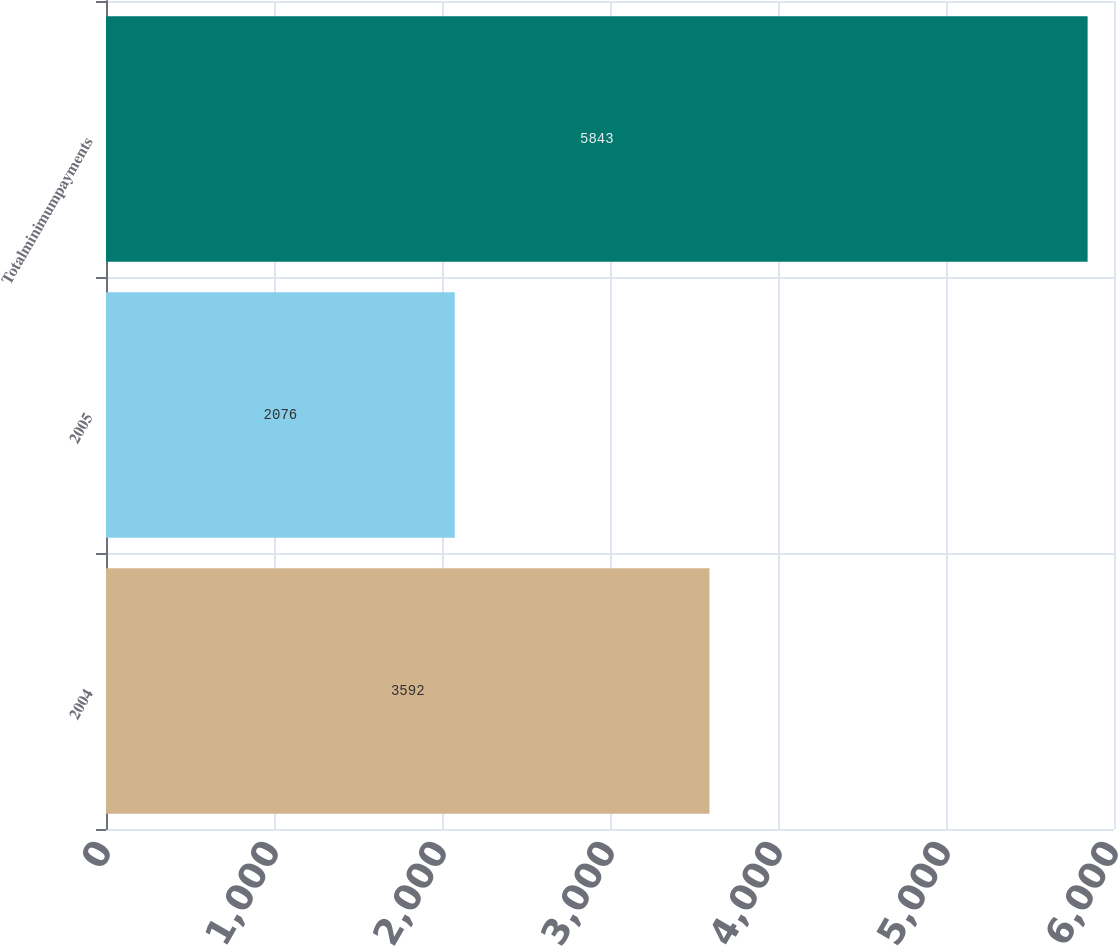Convert chart. <chart><loc_0><loc_0><loc_500><loc_500><bar_chart><fcel>2004<fcel>2005<fcel>Totalminimumpayments<nl><fcel>3592<fcel>2076<fcel>5843<nl></chart> 